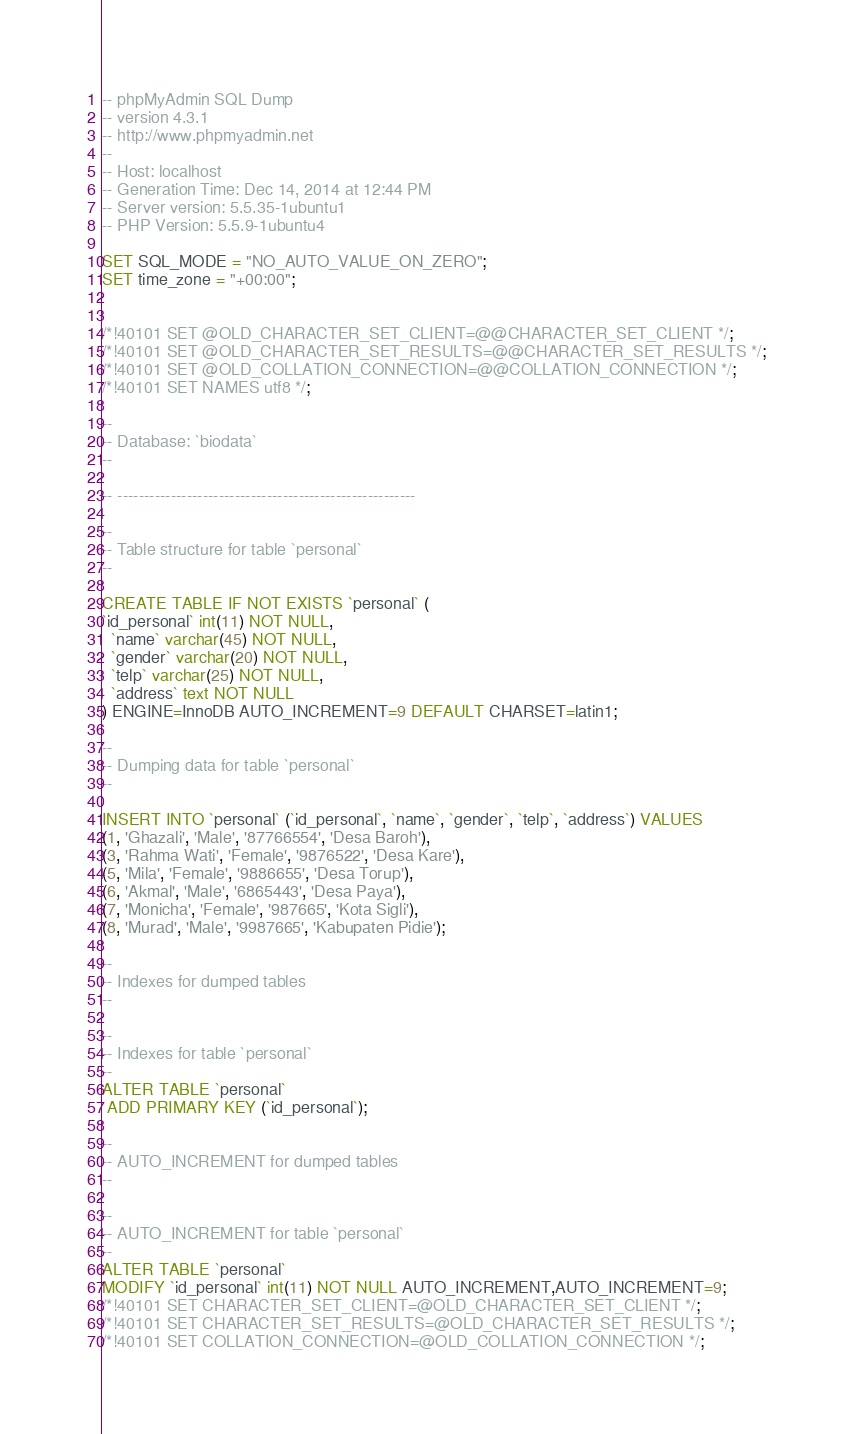Convert code to text. <code><loc_0><loc_0><loc_500><loc_500><_SQL_>-- phpMyAdmin SQL Dump
-- version 4.3.1
-- http://www.phpmyadmin.net
--
-- Host: localhost
-- Generation Time: Dec 14, 2014 at 12:44 PM
-- Server version: 5.5.35-1ubuntu1
-- PHP Version: 5.5.9-1ubuntu4

SET SQL_MODE = "NO_AUTO_VALUE_ON_ZERO";
SET time_zone = "+00:00";


/*!40101 SET @OLD_CHARACTER_SET_CLIENT=@@CHARACTER_SET_CLIENT */;
/*!40101 SET @OLD_CHARACTER_SET_RESULTS=@@CHARACTER_SET_RESULTS */;
/*!40101 SET @OLD_COLLATION_CONNECTION=@@COLLATION_CONNECTION */;
/*!40101 SET NAMES utf8 */;

--
-- Database: `biodata`
--

-- --------------------------------------------------------

--
-- Table structure for table `personal`
--

CREATE TABLE IF NOT EXISTS `personal` (
`id_personal` int(11) NOT NULL,
  `name` varchar(45) NOT NULL,
  `gender` varchar(20) NOT NULL,
  `telp` varchar(25) NOT NULL,
  `address` text NOT NULL
) ENGINE=InnoDB AUTO_INCREMENT=9 DEFAULT CHARSET=latin1;

--
-- Dumping data for table `personal`
--

INSERT INTO `personal` (`id_personal`, `name`, `gender`, `telp`, `address`) VALUES
(1, 'Ghazali', 'Male', '87766554', 'Desa Baroh'),
(3, 'Rahma Wati', 'Female', '9876522', 'Desa Kare'),
(5, 'Mila', 'Female', '9886655', 'Desa Torup'),
(6, 'Akmal', 'Male', '6865443', 'Desa Paya'),
(7, 'Monicha', 'Female', '987665', 'Kota Sigli'),
(8, 'Murad', 'Male', '9987665', 'Kabupaten Pidie');

--
-- Indexes for dumped tables
--

--
-- Indexes for table `personal`
--
ALTER TABLE `personal`
 ADD PRIMARY KEY (`id_personal`);

--
-- AUTO_INCREMENT for dumped tables
--

--
-- AUTO_INCREMENT for table `personal`
--
ALTER TABLE `personal`
MODIFY `id_personal` int(11) NOT NULL AUTO_INCREMENT,AUTO_INCREMENT=9;
/*!40101 SET CHARACTER_SET_CLIENT=@OLD_CHARACTER_SET_CLIENT */;
/*!40101 SET CHARACTER_SET_RESULTS=@OLD_CHARACTER_SET_RESULTS */;
/*!40101 SET COLLATION_CONNECTION=@OLD_COLLATION_CONNECTION */;
</code> 